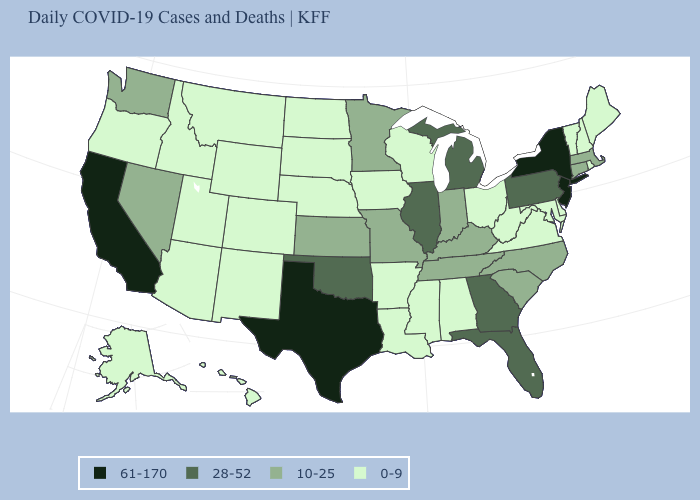Among the states that border Ohio , which have the lowest value?
Give a very brief answer. West Virginia. Which states hav the highest value in the MidWest?
Keep it brief. Illinois, Michigan. What is the value of Rhode Island?
Be succinct. 0-9. Name the states that have a value in the range 10-25?
Quick response, please. Connecticut, Indiana, Kansas, Kentucky, Massachusetts, Minnesota, Missouri, Nevada, North Carolina, South Carolina, Tennessee, Washington. Name the states that have a value in the range 10-25?
Be succinct. Connecticut, Indiana, Kansas, Kentucky, Massachusetts, Minnesota, Missouri, Nevada, North Carolina, South Carolina, Tennessee, Washington. What is the lowest value in the Northeast?
Answer briefly. 0-9. What is the value of Colorado?
Give a very brief answer. 0-9. Does California have the same value as New Jersey?
Quick response, please. Yes. Does New Jersey have the highest value in the USA?
Concise answer only. Yes. What is the value of Kentucky?
Quick response, please. 10-25. Which states have the lowest value in the USA?
Short answer required. Alabama, Alaska, Arizona, Arkansas, Colorado, Delaware, Hawaii, Idaho, Iowa, Louisiana, Maine, Maryland, Mississippi, Montana, Nebraska, New Hampshire, New Mexico, North Dakota, Ohio, Oregon, Rhode Island, South Dakota, Utah, Vermont, Virginia, West Virginia, Wisconsin, Wyoming. Name the states that have a value in the range 61-170?
Quick response, please. California, New Jersey, New York, Texas. Does Iowa have a lower value than Wisconsin?
Short answer required. No. Which states hav the highest value in the West?
Keep it brief. California. Among the states that border Illinois , does Iowa have the highest value?
Answer briefly. No. 